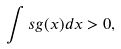<formula> <loc_0><loc_0><loc_500><loc_500>\int s g ( x ) d x > 0 ,</formula> 